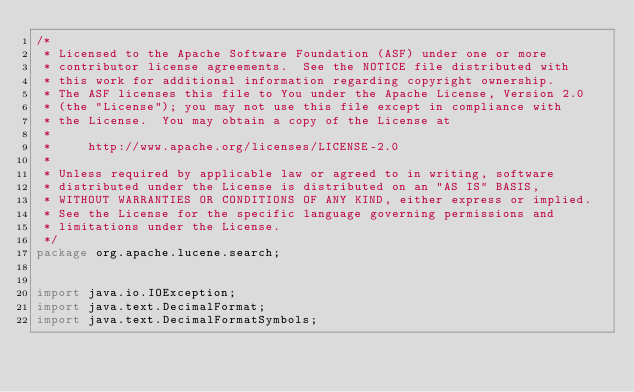Convert code to text. <code><loc_0><loc_0><loc_500><loc_500><_Java_>/*
 * Licensed to the Apache Software Foundation (ASF) under one or more
 * contributor license agreements.  See the NOTICE file distributed with
 * this work for additional information regarding copyright ownership.
 * The ASF licenses this file to You under the Apache License, Version 2.0
 * (the "License"); you may not use this file except in compliance with
 * the License.  You may obtain a copy of the License at
 *
 *     http://www.apache.org/licenses/LICENSE-2.0
 *
 * Unless required by applicable law or agreed to in writing, software
 * distributed under the License is distributed on an "AS IS" BASIS,
 * WITHOUT WARRANTIES OR CONDITIONS OF ANY KIND, either express or implied.
 * See the License for the specific language governing permissions and
 * limitations under the License.
 */
package org.apache.lucene.search;


import java.io.IOException;
import java.text.DecimalFormat;
import java.text.DecimalFormatSymbols;</code> 